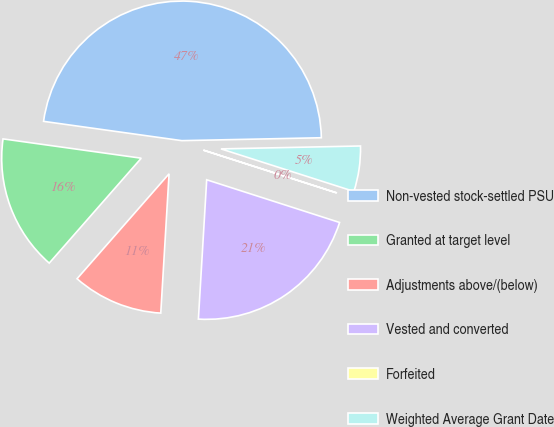Convert chart. <chart><loc_0><loc_0><loc_500><loc_500><pie_chart><fcel>Non-vested stock-settled PSU<fcel>Granted at target level<fcel>Adjustments above/(below)<fcel>Vested and converted<fcel>Forfeited<fcel>Weighted Average Grant Date<nl><fcel>47.46%<fcel>15.75%<fcel>10.51%<fcel>21.0%<fcel>0.02%<fcel>5.26%<nl></chart> 